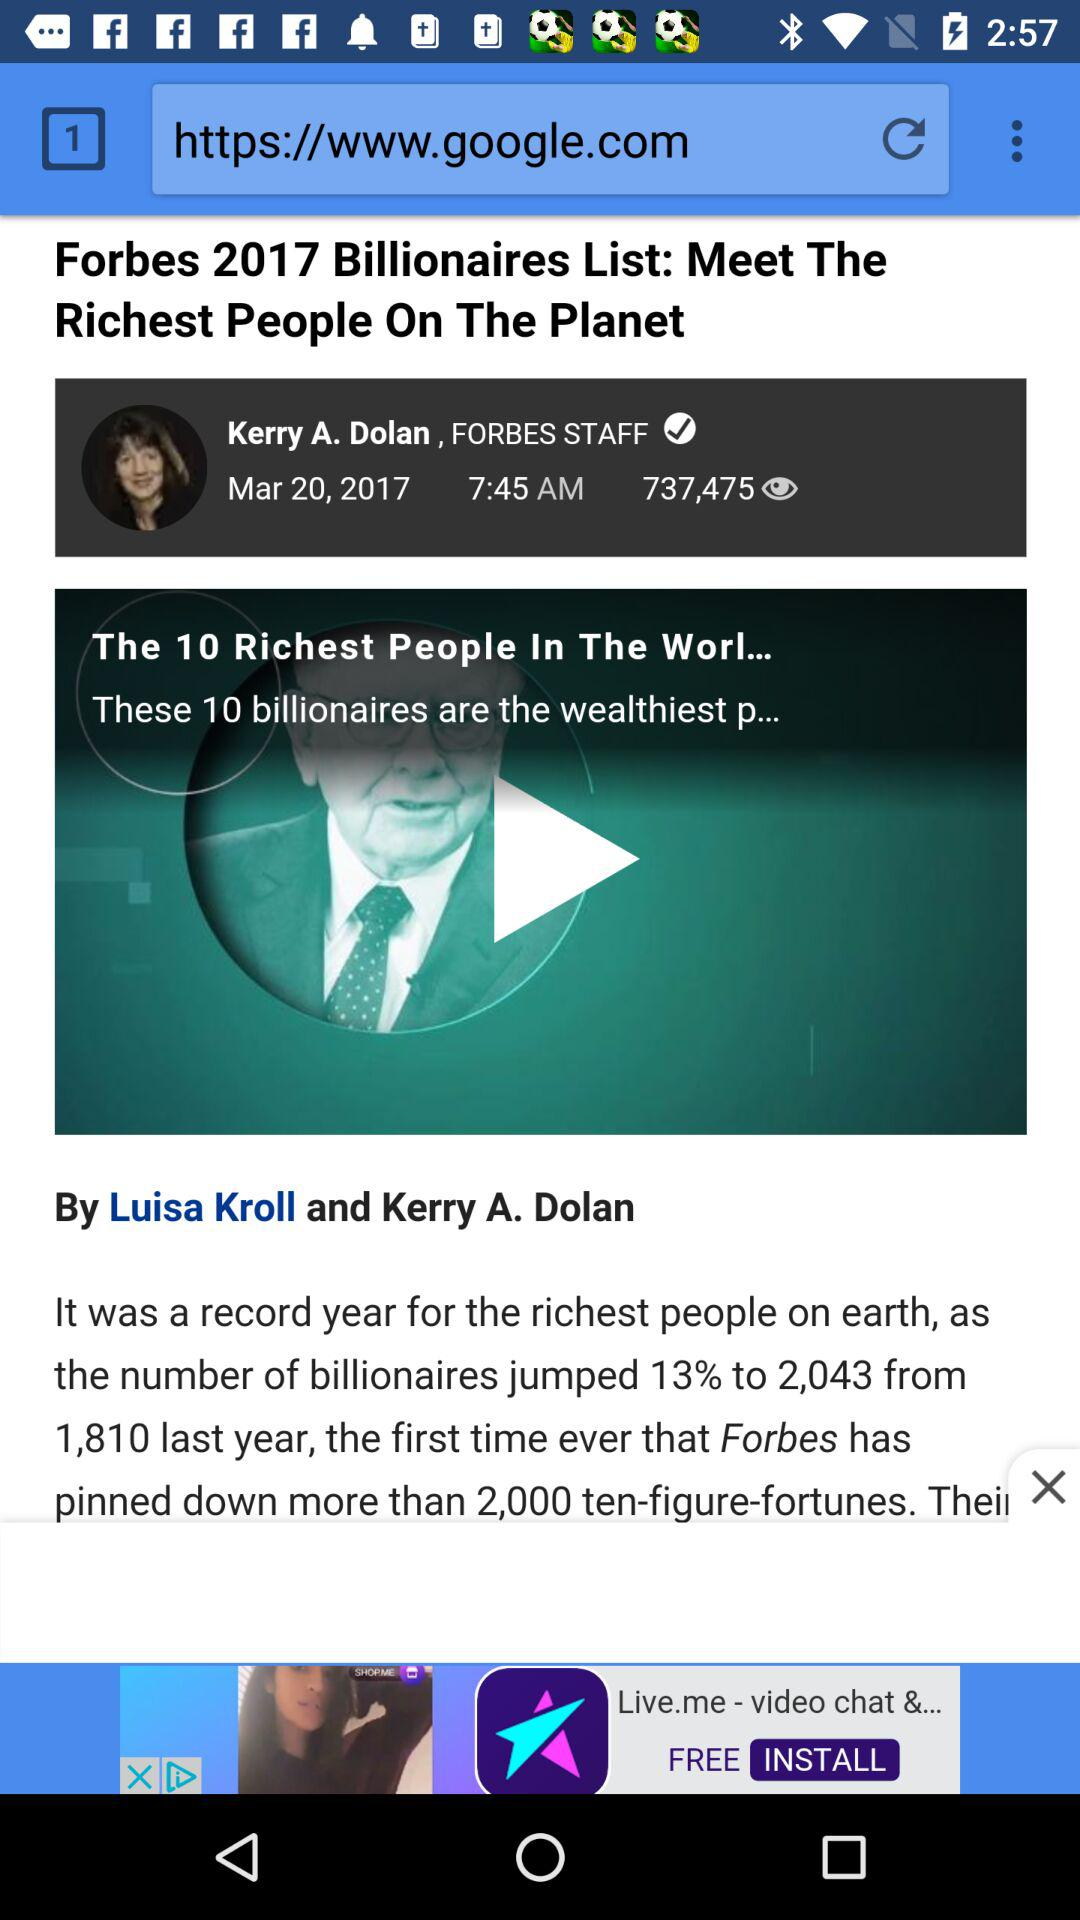Who posted the news "Forbes Billionaires List: Meet The Richest People On The Planet"? The news was posted by Kerry A. Dolan, FORBES STAFF. 